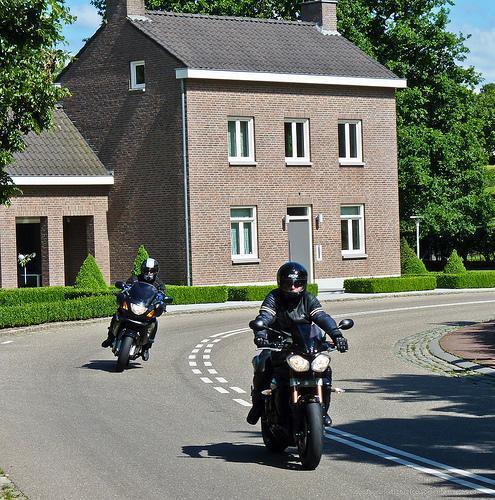How many people are in the picture?
Give a very brief answer. 2. 